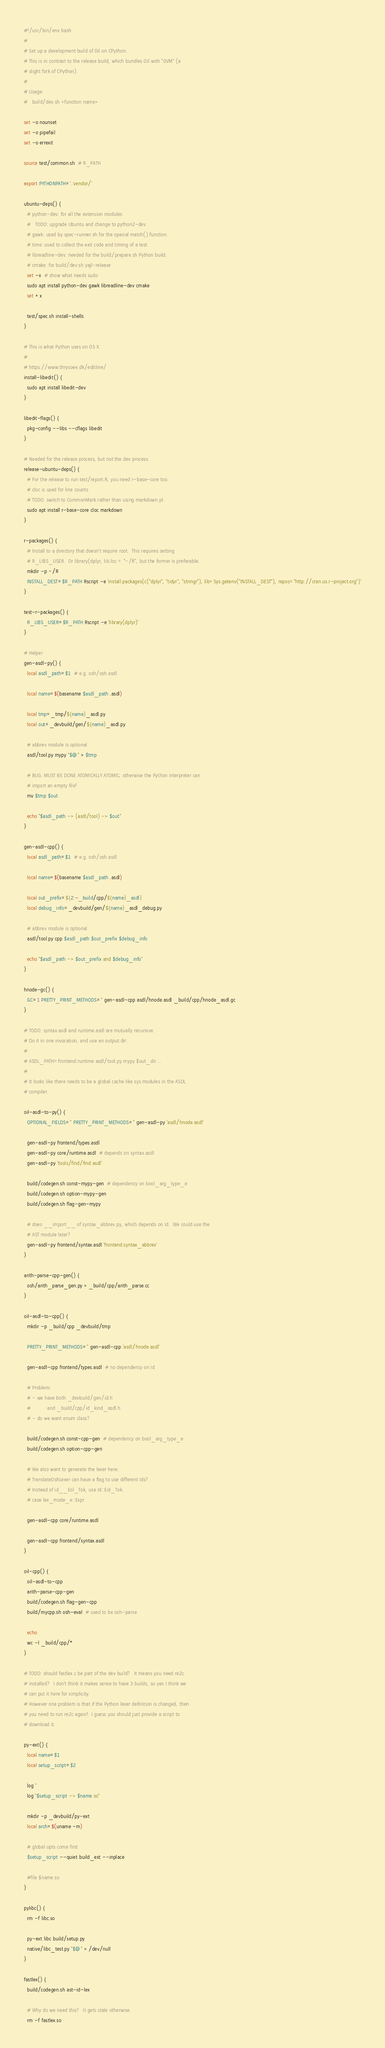<code> <loc_0><loc_0><loc_500><loc_500><_Bash_>#!/usr/bin/env bash
#
# Set up a development build of Oil on CPython.
# This is in contrast to the release build, which bundles Oil with "OVM" (a
# slight fork of CPython).
#
# Usage:
#   build/dev.sh <function name>

set -o nounset
set -o pipefail
set -o errexit

source test/common.sh  # R_PATH

export PYTHONPATH='.:vendor/'

ubuntu-deps() {
  # python-dev: for all the extension modules
  #   TODO: upgrade Ubuntu and change to python2-dev
  # gawk: used by spec-runner.sh for the special match() function.
  # time: used to collect the exit code and timing of a test
  # libreadline-dev: needed for the build/prepare.sh Python build.
  # cmake: for build/dev.sh yajl-release
  set -x  # show what needs sudo
  sudo apt install python-dev gawk libreadline-dev cmake
  set +x

  test/spec.sh install-shells
}

# This is what Python uses on OS X.
#
# https://www.thrysoee.dk/editline/
install-libedit() {
  sudo apt install libedit-dev
}

libedit-flags() {
  pkg-config --libs --cflags libedit
}

# Needed for the release process, but not the dev process.
release-ubuntu-deps() {
  # For the release to run test/report.R, you need r-base-core too.
  # cloc is used for line counts
  # TODO: switch to CommonMark rather than using markdown.pl.
  sudo apt install r-base-core cloc markdown
}

r-packages() {
  # Install to a directory that doesn't require root.  This requires setting
  # R_LIBS_USER.  Or library(dplyr, lib.loc = "~/R", but the former is preferable.
  mkdir -p ~/R
  INSTALL_DEST=$R_PATH Rscript -e 'install.packages(c("dplyr", "tidyr", "stringr"), lib=Sys.getenv("INSTALL_DEST"), repos="http://cran.us.r-project.org")'
}

test-r-packages() {
  R_LIBS_USER=$R_PATH Rscript -e 'library(dplyr)'
}

# Helper
gen-asdl-py() {
  local asdl_path=$1  # e.g. osh/osh.asdl

  local name=$(basename $asdl_path .asdl)

  local tmp=_tmp/${name}_asdl.py
  local out=_devbuild/gen/${name}_asdl.py

  # abbrev module is optional
  asdl/tool.py mypy "$@" > $tmp

  # BUG: MUST BE DONE ATOMICALLY ATOMIC; otherwise the Python interpreter can
  # import an empty file!
  mv $tmp $out

  echo "$asdl_path -> (asdl/tool) -> $out"
}

gen-asdl-cpp() {
  local asdl_path=$1  # e.g. osh/osh.asdl

  local name=$(basename $asdl_path .asdl)

  local out_prefix=${2:-_build/cpp/${name}_asdl}
  local debug_info=_devbuild/gen/${name}_asdl_debug.py

  # abbrev module is optional
  asdl/tool.py cpp $asdl_path $out_prefix $debug_info

  echo "$asdl_path -> $out_prefix and $debug_info"
}

hnode-gc() {
  GC=1 PRETTY_PRINT_METHODS='' gen-asdl-cpp asdl/hnode.asdl _build/cpp/hnode_asdl.gc
}

# TODO: syntax.asdl and runtime.asdl are mutually recursive.
# Do it in one invocation, and use an output dir:
#
# ASDL_PATH=frontend:runtime asdl/tool.py mypy $out_dir ...
#
# It looks like there needs to be a global cache like sys.modules in the ASDL
# compiler.

oil-asdl-to-py() {
  OPTIONAL_FIELDS='' PRETTY_PRINT_METHODS='' gen-asdl-py 'asdl/hnode.asdl'

  gen-asdl-py frontend/types.asdl
  gen-asdl-py core/runtime.asdl  # depends on syntax.asdl
  gen-asdl-py 'tools/find/find.asdl'

  build/codegen.sh const-mypy-gen  # dependency on bool_arg_type_e
  build/codegen.sh option-mypy-gen
  build/codegen.sh flag-gen-mypy

  # does __import__ of syntax_abbrev.py, which depends on Id.  We could use the
  # AST module later?
  gen-asdl-py frontend/syntax.asdl 'frontend.syntax_abbrev'
}

arith-parse-cpp-gen() {
  osh/arith_parse_gen.py > _build/cpp/arith_parse.cc
}

oil-asdl-to-cpp() {
  mkdir -p _build/cpp _devbuild/tmp

  PRETTY_PRINT_METHODS='' gen-asdl-cpp 'asdl/hnode.asdl'

  gen-asdl-cpp frontend/types.asdl  # no dependency on Id

  # Problem:
  # - we have both _devbuild/gen/id.h 
  #           and _build/cpp/id_kind_asdl.h
  # - do we want enum class?

  build/codegen.sh const-cpp-gen  # dependency on bool_arg_type_e
  build/codegen.sh option-cpp-gen

  # We also want to generate the lexer here.
  # TranslateOshLexer can have a flag to use different Ids?
  # Instead of id__Eol_Tok, use Id::Eol_Tok.
  # case lex_mode_e::Expr

  gen-asdl-cpp core/runtime.asdl

  gen-asdl-cpp frontend/syntax.asdl
}

oil-cpp() {
  oil-asdl-to-cpp
  arith-parse-cpp-gen
  build/codegen.sh flag-gen-cpp
  build/mycpp.sh osh-eval  # used to be osh-parse

  echo
  wc -l _build/cpp/*
}

# TODO: should fastlex.c be part of the dev build?  It means you need re2c
# installed?  I don't think it makes sense to have 3 builds, so yes I think we
# can put it here for simplicity.
# However one problem is that if the Python lexer definition is changed, then
# you need to run re2c again!  I guess you should just provide a script to
# download it.

py-ext() {
  local name=$1
  local setup_script=$2

  log ''
  log "$setup_script -> $name.so"

  mkdir -p _devbuild/py-ext
  local arch=$(uname -m)

  # global opts come first
  $setup_script --quiet build_ext --inplace

  #file $name.so
}

pylibc() {
  rm -f libc.so

  py-ext libc build/setup.py
  native/libc_test.py "$@" > /dev/null
}

fastlex() {
  build/codegen.sh ast-id-lex

  # Why do we need this?  It gets stale otherwise.
  rm -f fastlex.so
</code> 